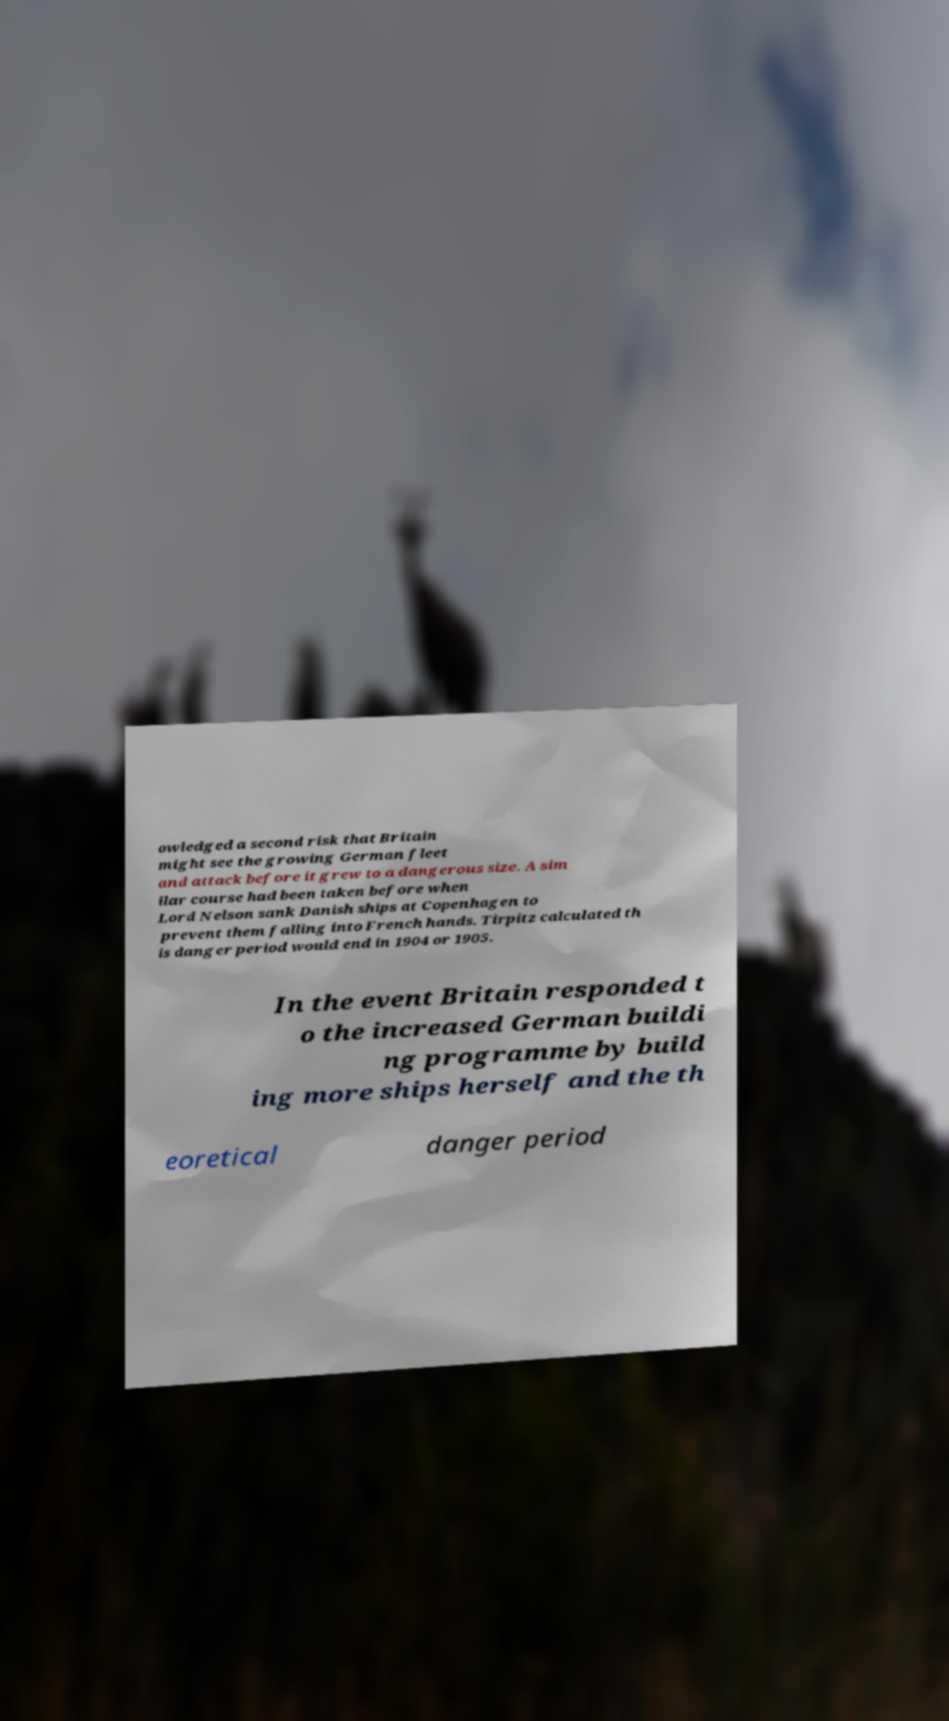For documentation purposes, I need the text within this image transcribed. Could you provide that? owledged a second risk that Britain might see the growing German fleet and attack before it grew to a dangerous size. A sim ilar course had been taken before when Lord Nelson sank Danish ships at Copenhagen to prevent them falling into French hands. Tirpitz calculated th is danger period would end in 1904 or 1905. In the event Britain responded t o the increased German buildi ng programme by build ing more ships herself and the th eoretical danger period 